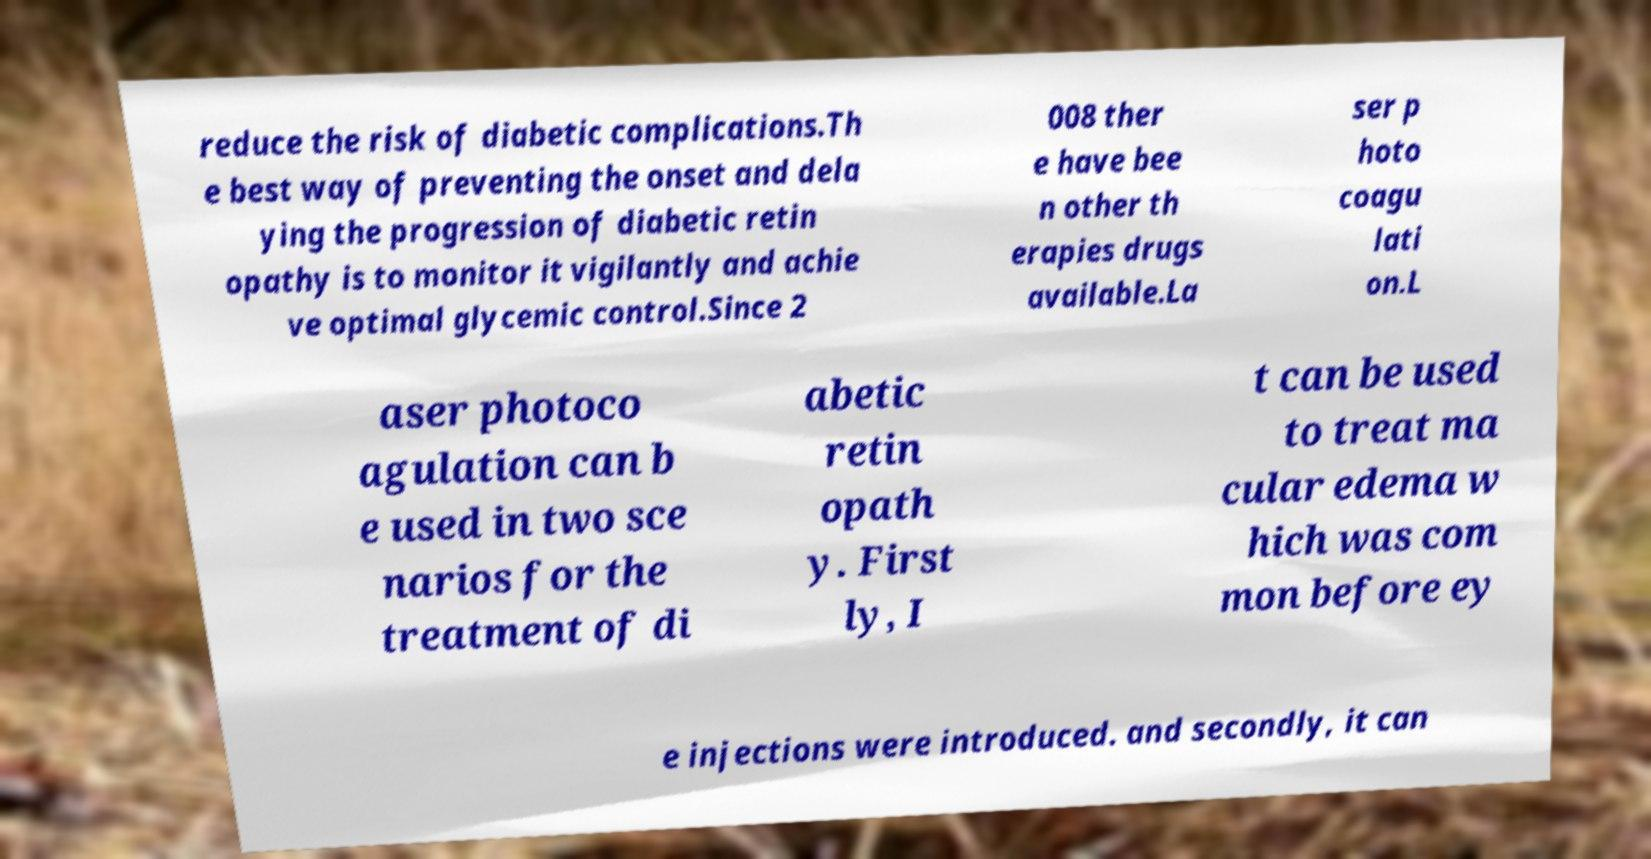Please read and relay the text visible in this image. What does it say? reduce the risk of diabetic complications.Th e best way of preventing the onset and dela ying the progression of diabetic retin opathy is to monitor it vigilantly and achie ve optimal glycemic control.Since 2 008 ther e have bee n other th erapies drugs available.La ser p hoto coagu lati on.L aser photoco agulation can b e used in two sce narios for the treatment of di abetic retin opath y. First ly, I t can be used to treat ma cular edema w hich was com mon before ey e injections were introduced. and secondly, it can 